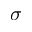Convert formula to latex. <formula><loc_0><loc_0><loc_500><loc_500>\sigma</formula> 